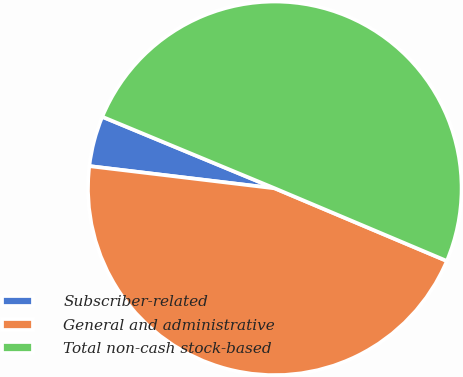<chart> <loc_0><loc_0><loc_500><loc_500><pie_chart><fcel>Subscriber-related<fcel>General and administrative<fcel>Total non-cash stock-based<nl><fcel>4.36%<fcel>45.54%<fcel>50.1%<nl></chart> 